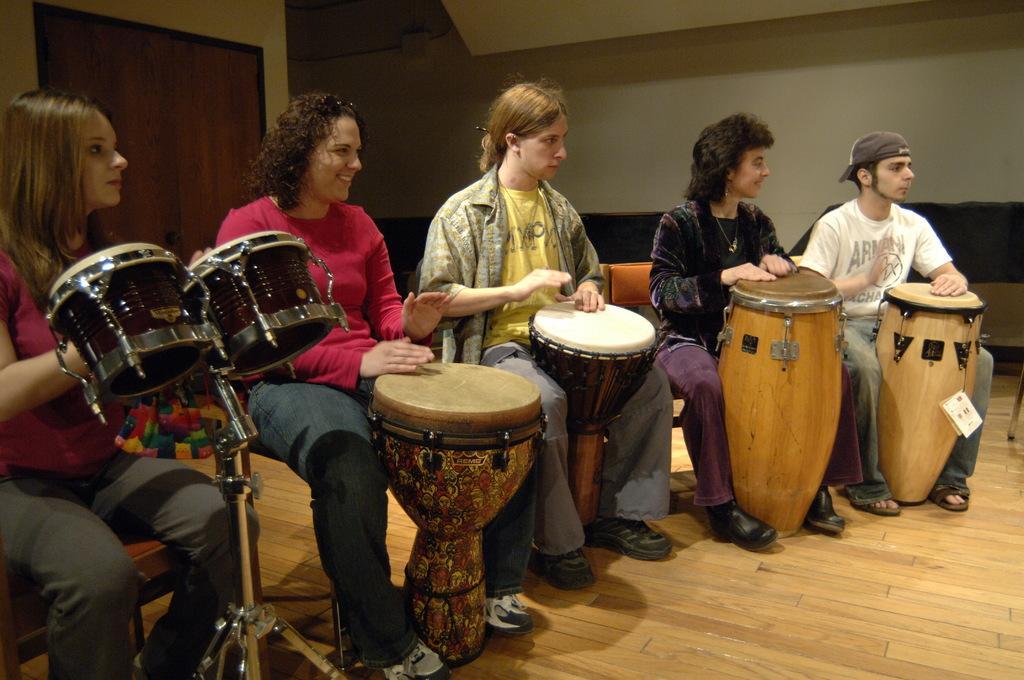In one or two sentences, can you explain what this image depicts? In the picture there are total five people sitting on the chair and all of them are playing different kind of drums,in the background there is a wall to the left there is a door. 